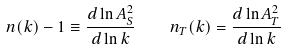Convert formula to latex. <formula><loc_0><loc_0><loc_500><loc_500>n ( k ) - 1 \equiv \frac { d \ln A _ { S } ^ { 2 } } { d \ln k } \quad n _ { T } ( k ) = \frac { d \ln A _ { T } ^ { 2 } } { d \ln k } \,</formula> 